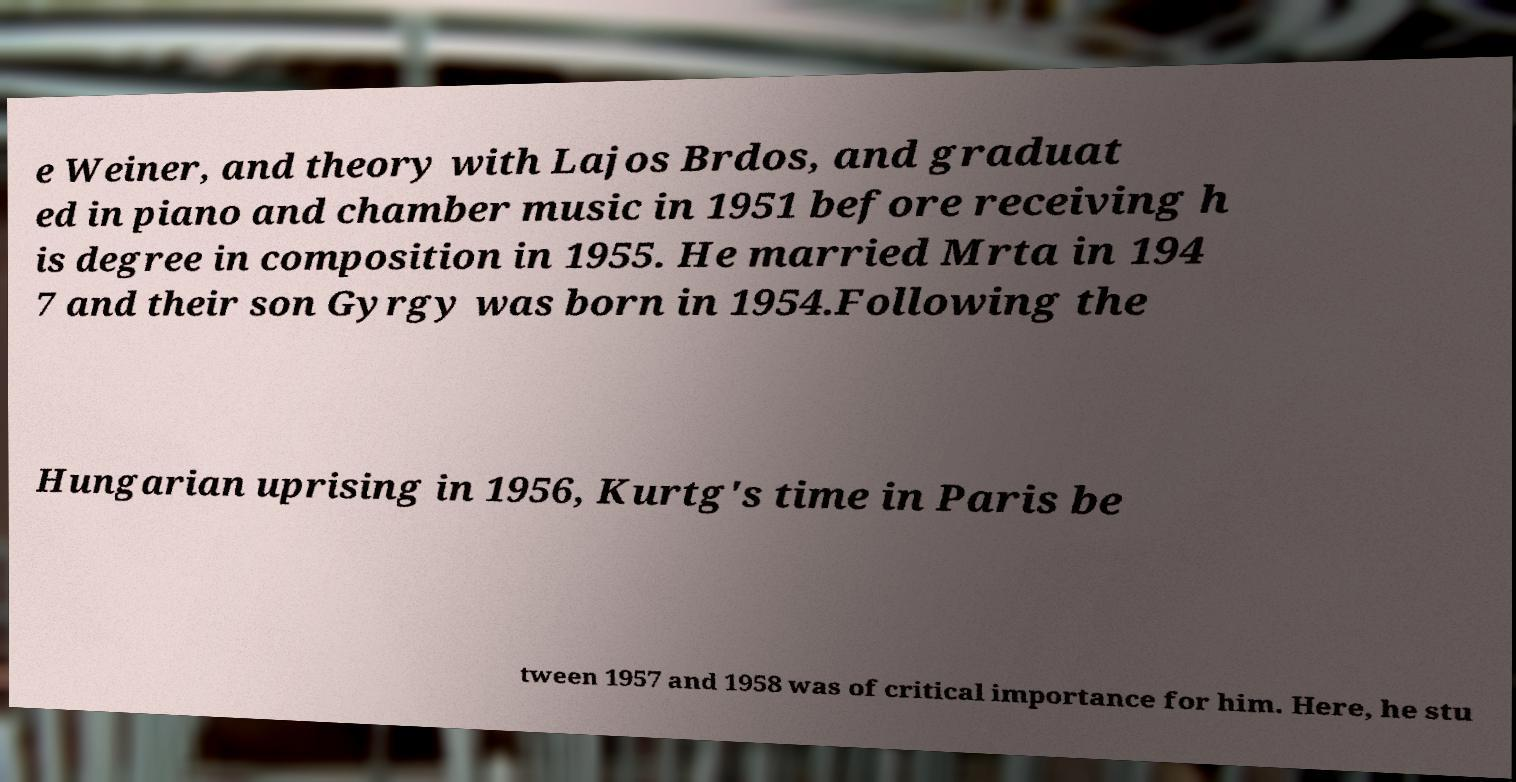Could you extract and type out the text from this image? e Weiner, and theory with Lajos Brdos, and graduat ed in piano and chamber music in 1951 before receiving h is degree in composition in 1955. He married Mrta in 194 7 and their son Gyrgy was born in 1954.Following the Hungarian uprising in 1956, Kurtg's time in Paris be tween 1957 and 1958 was of critical importance for him. Here, he stu 